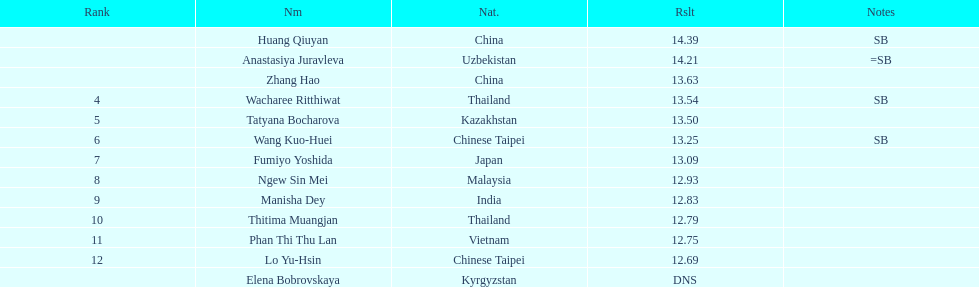From thailand, how many contestants took part? 2. 